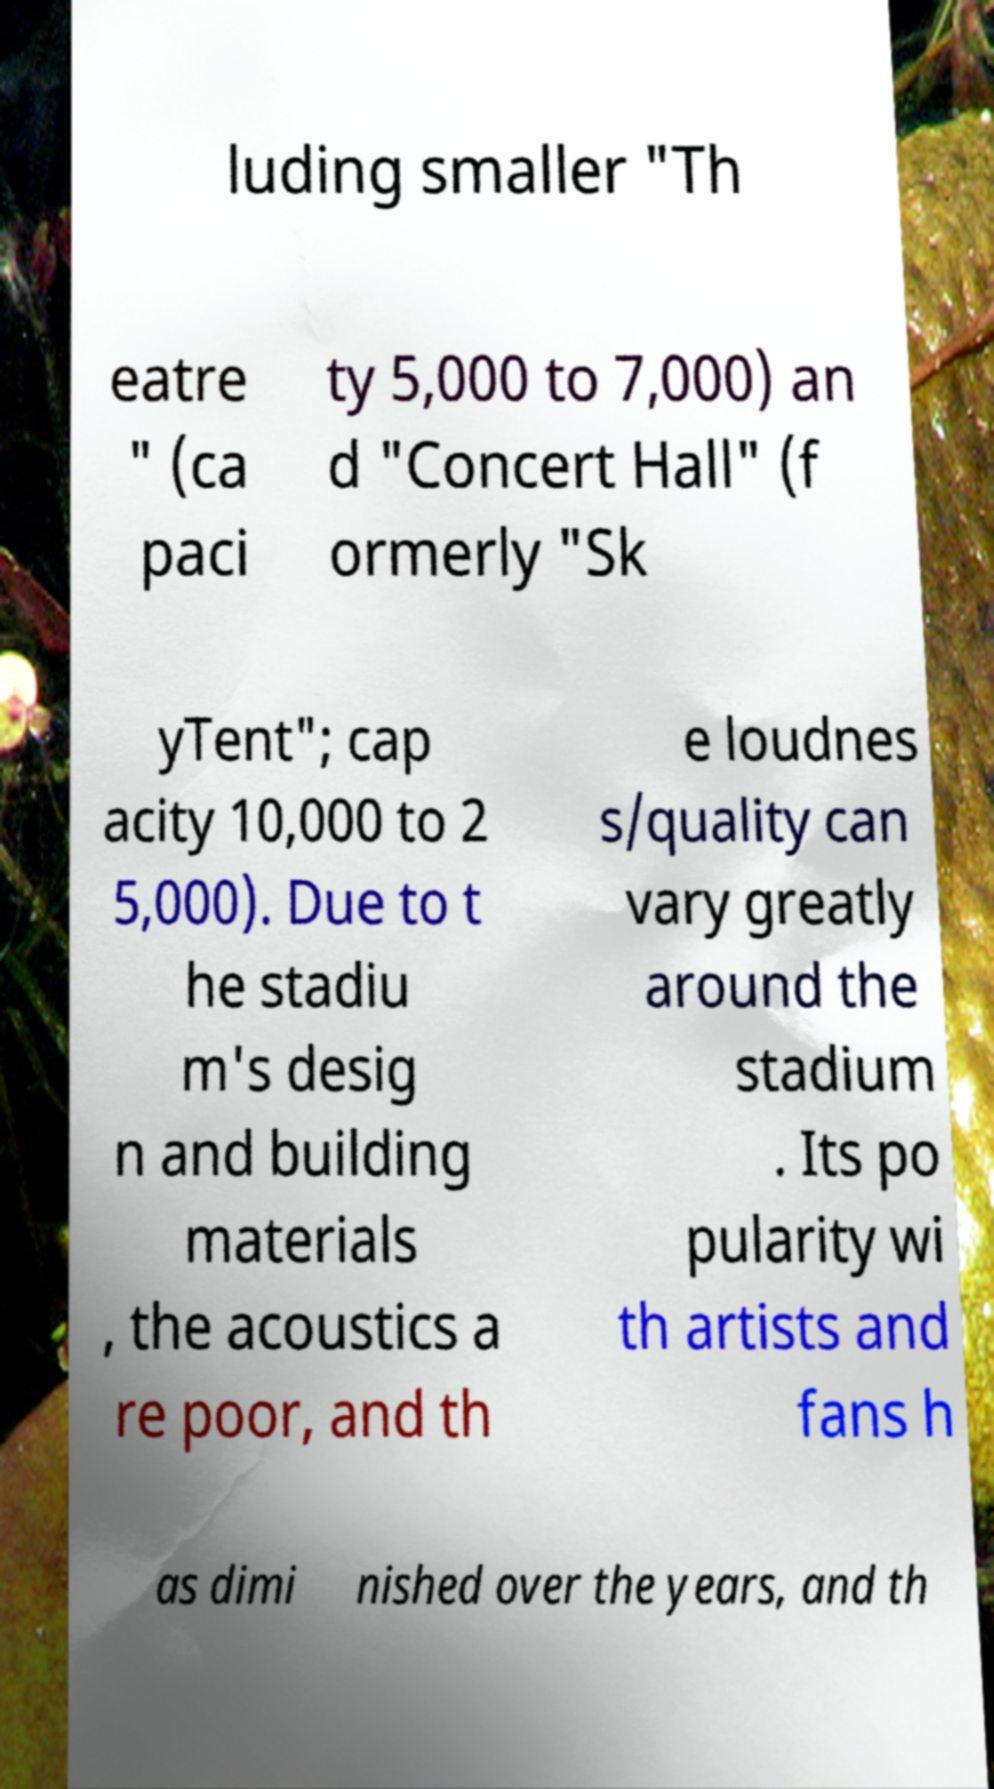Please read and relay the text visible in this image. What does it say? luding smaller "Th eatre " (ca paci ty 5,000 to 7,000) an d "Concert Hall" (f ormerly "Sk yTent"; cap acity 10,000 to 2 5,000). Due to t he stadiu m's desig n and building materials , the acoustics a re poor, and th e loudnes s/quality can vary greatly around the stadium . Its po pularity wi th artists and fans h as dimi nished over the years, and th 